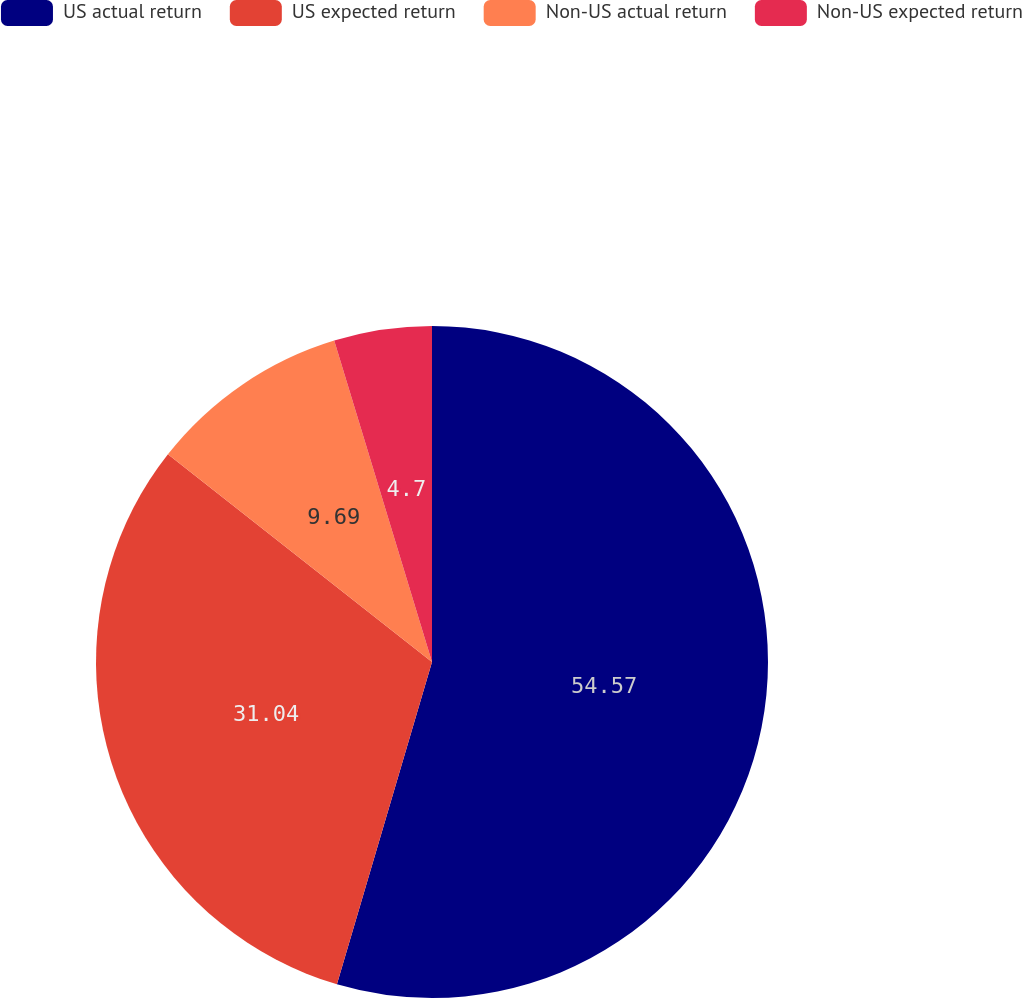<chart> <loc_0><loc_0><loc_500><loc_500><pie_chart><fcel>US actual return<fcel>US expected return<fcel>Non-US actual return<fcel>Non-US expected return<nl><fcel>54.56%<fcel>31.04%<fcel>9.69%<fcel>4.7%<nl></chart> 